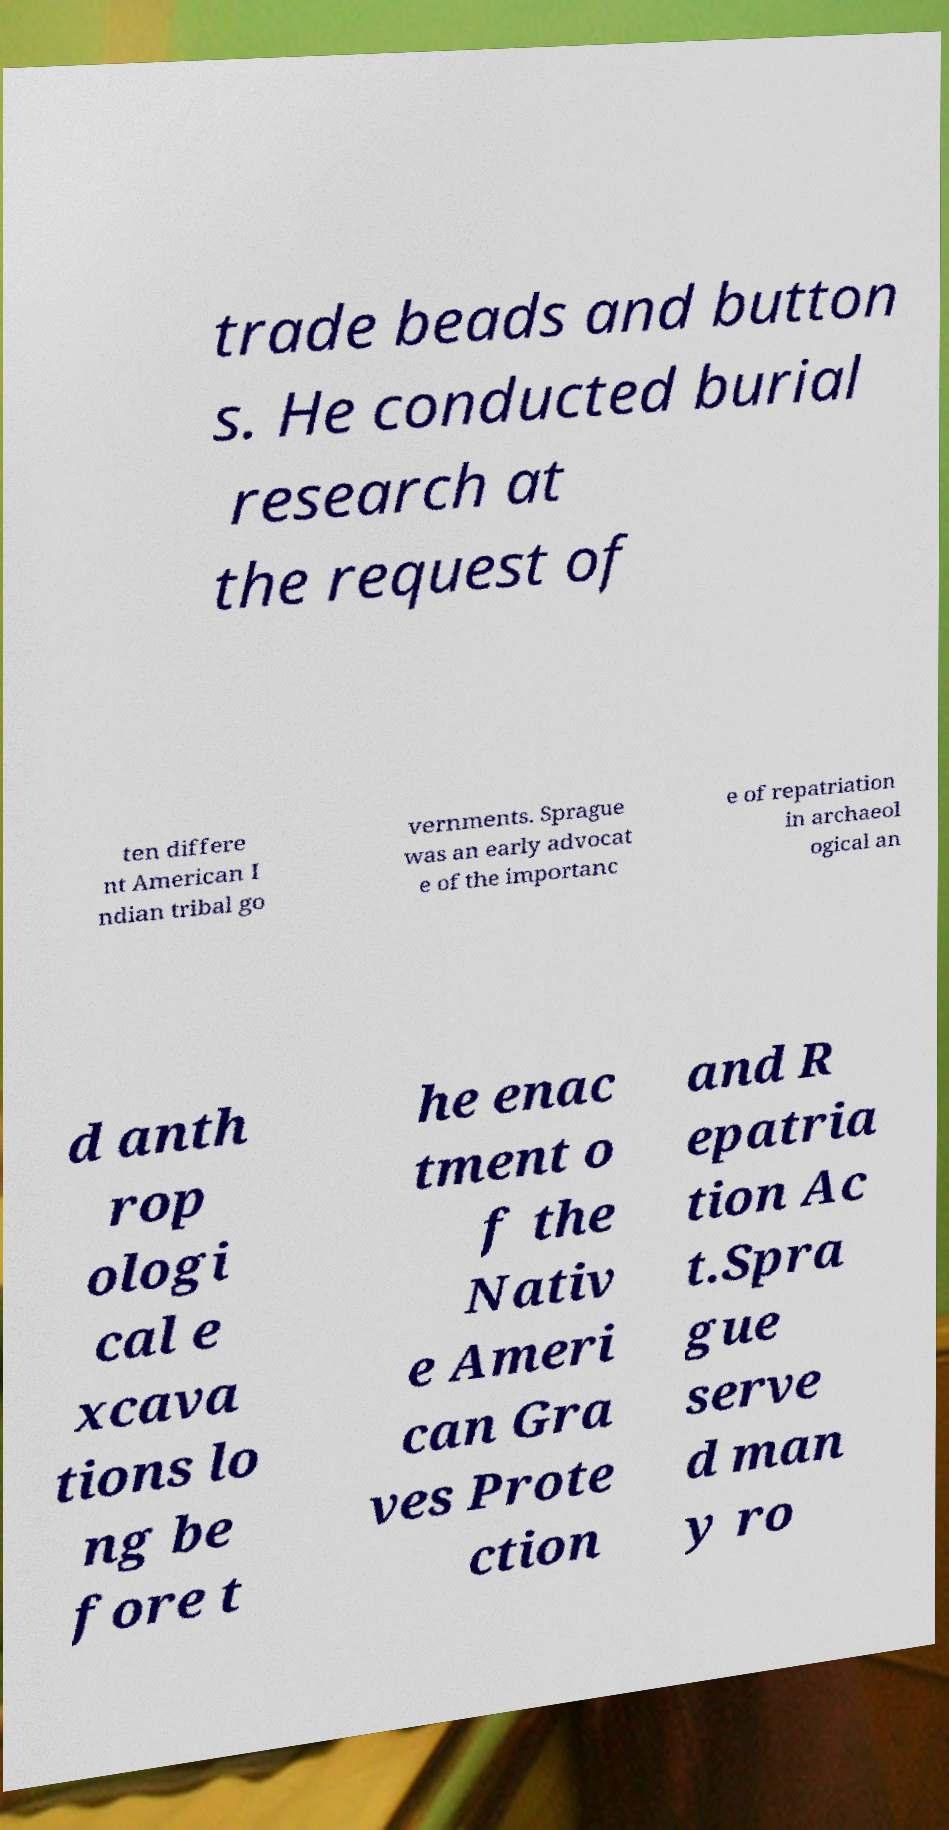For documentation purposes, I need the text within this image transcribed. Could you provide that? trade beads and button s. He conducted burial research at the request of ten differe nt American I ndian tribal go vernments. Sprague was an early advocat e of the importanc e of repatriation in archaeol ogical an d anth rop ologi cal e xcava tions lo ng be fore t he enac tment o f the Nativ e Ameri can Gra ves Prote ction and R epatria tion Ac t.Spra gue serve d man y ro 